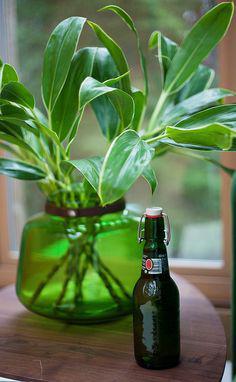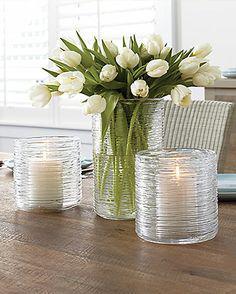The first image is the image on the left, the second image is the image on the right. Given the left and right images, does the statement "A clear glass vase of yellow and orange tulips is near a sofa in front of a window." hold true? Answer yes or no. No. The first image is the image on the left, the second image is the image on the right. Considering the images on both sides, is "There is a clear glass vase with red tulips in one image and a bouquet in a different kind of container in the second image." valid? Answer yes or no. No. 